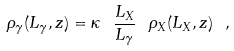<formula> <loc_0><loc_0><loc_500><loc_500>\rho _ { \gamma } ( L _ { \gamma } , z ) = \kappa \ \frac { L _ { X } } { L _ { \gamma } } \ \rho _ { X } ( L _ { X } , z ) \ ,</formula> 